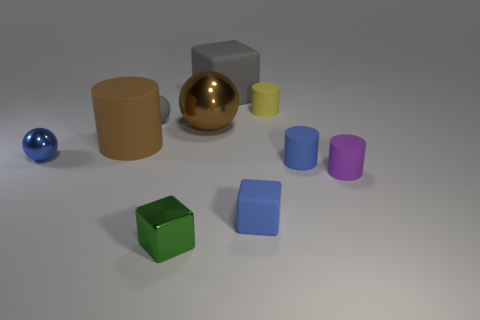There is a tiny rubber ball; does it have the same color as the big matte object that is behind the tiny rubber sphere?
Offer a terse response. Yes. What number of other objects are there of the same material as the blue cylinder?
Your response must be concise. 6. The large gray object that is the same material as the yellow thing is what shape?
Your answer should be compact. Cube. Is there anything else that is the same color as the tiny metal block?
Offer a very short reply. No. There is a thing that is the same color as the matte sphere; what size is it?
Give a very brief answer. Large. Is the number of big matte objects that are on the left side of the brown shiny sphere greater than the number of green matte blocks?
Offer a very short reply. Yes. There is a tiny gray matte thing; is its shape the same as the blue thing that is right of the blue cube?
Offer a terse response. No. What number of matte blocks are the same size as the green shiny object?
Make the answer very short. 1. There is a shiny sphere behind the shiny thing that is to the left of the big rubber cylinder; how many small metal cubes are behind it?
Your answer should be compact. 0. Are there the same number of small blue rubber cubes on the left side of the gray matte cube and large things that are in front of the rubber ball?
Keep it short and to the point. No. 